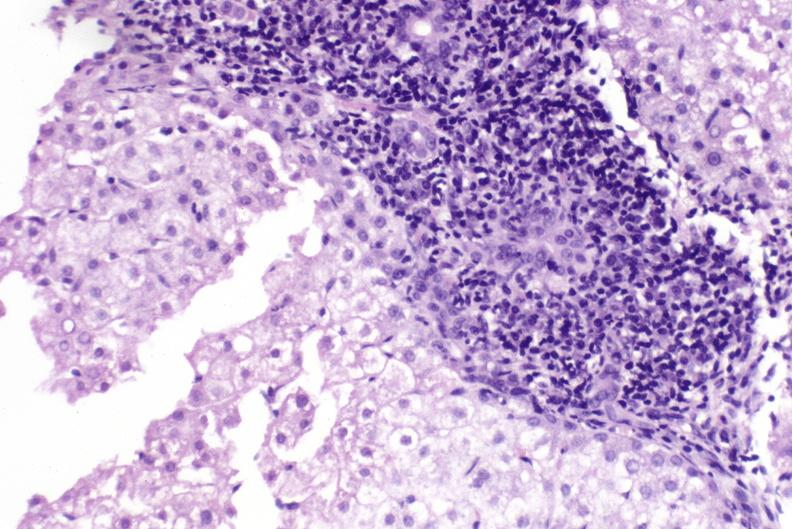does cachexia show primary biliary cirrhosis?
Answer the question using a single word or phrase. No 